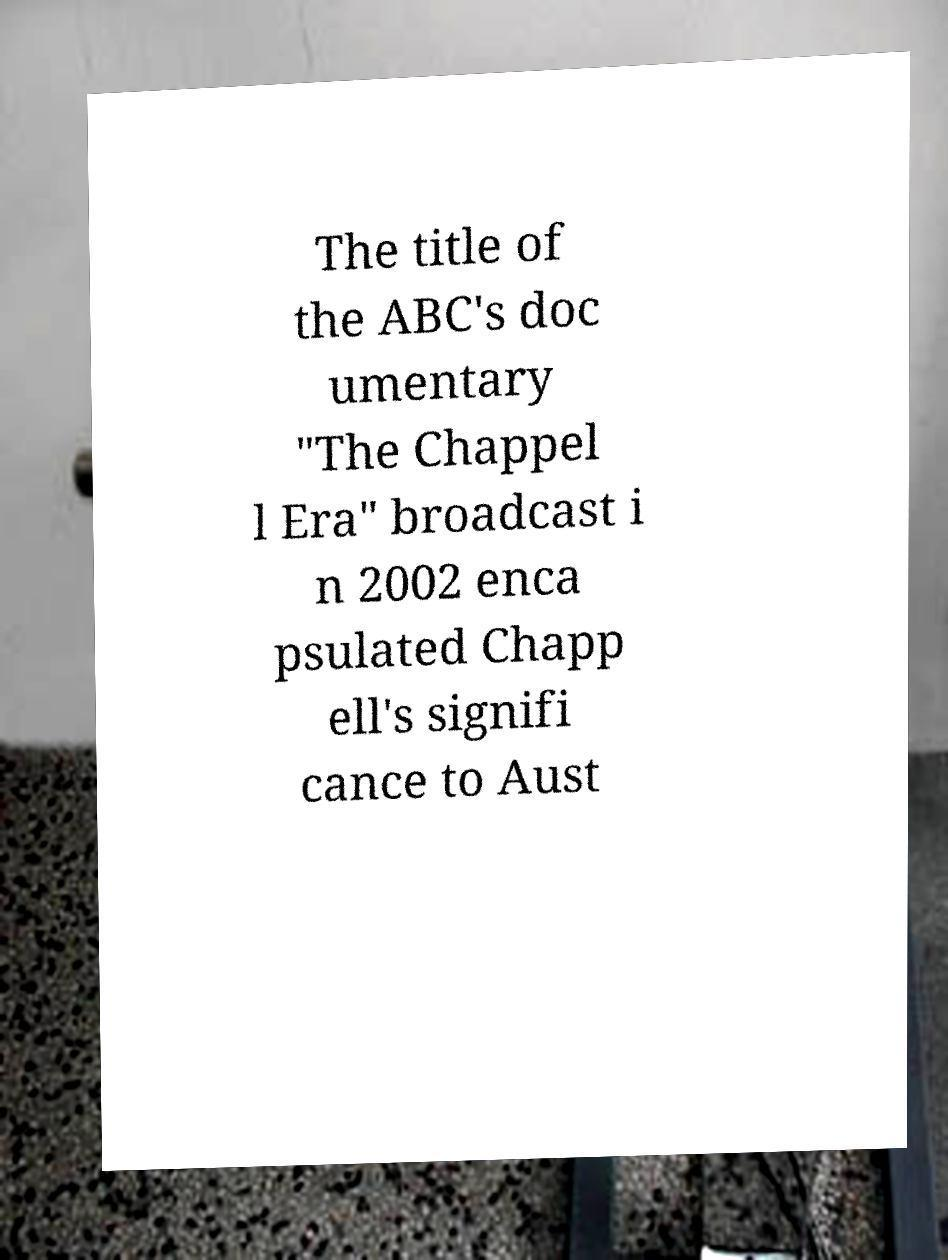For documentation purposes, I need the text within this image transcribed. Could you provide that? The title of the ABC's doc umentary "The Chappel l Era" broadcast i n 2002 enca psulated Chapp ell's signifi cance to Aust 